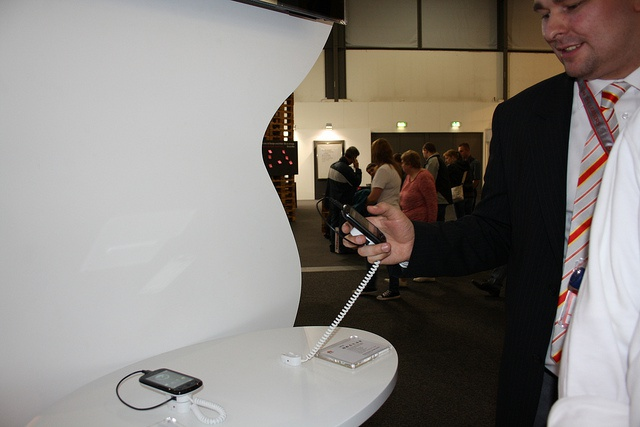Describe the objects in this image and their specific colors. I can see people in darkgray, black, maroon, and brown tones, people in darkgray and lightgray tones, tie in darkgray, brown, and gray tones, people in darkgray, black, gray, and maroon tones, and people in darkgray, black, maroon, and brown tones in this image. 